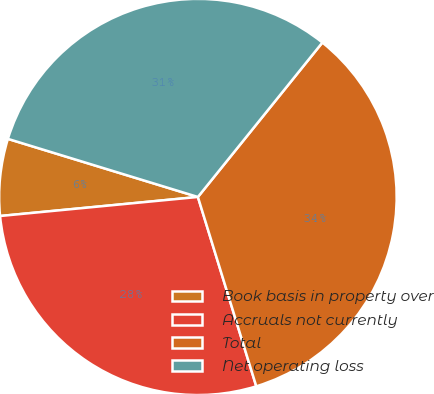Convert chart. <chart><loc_0><loc_0><loc_500><loc_500><pie_chart><fcel>Book basis in property over<fcel>Accruals not currently<fcel>Total<fcel>Net operating loss<nl><fcel>6.27%<fcel>28.21%<fcel>34.48%<fcel>31.03%<nl></chart> 